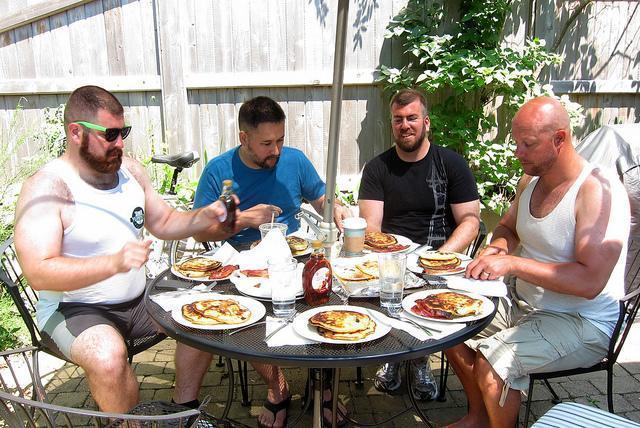How many men are in the picture?
Give a very brief answer. 4. How many men are bald?
Give a very brief answer. 1. How many bicycles are in the photo?
Give a very brief answer. 1. How many chairs are visible?
Give a very brief answer. 3. How many people are in the picture?
Give a very brief answer. 4. 